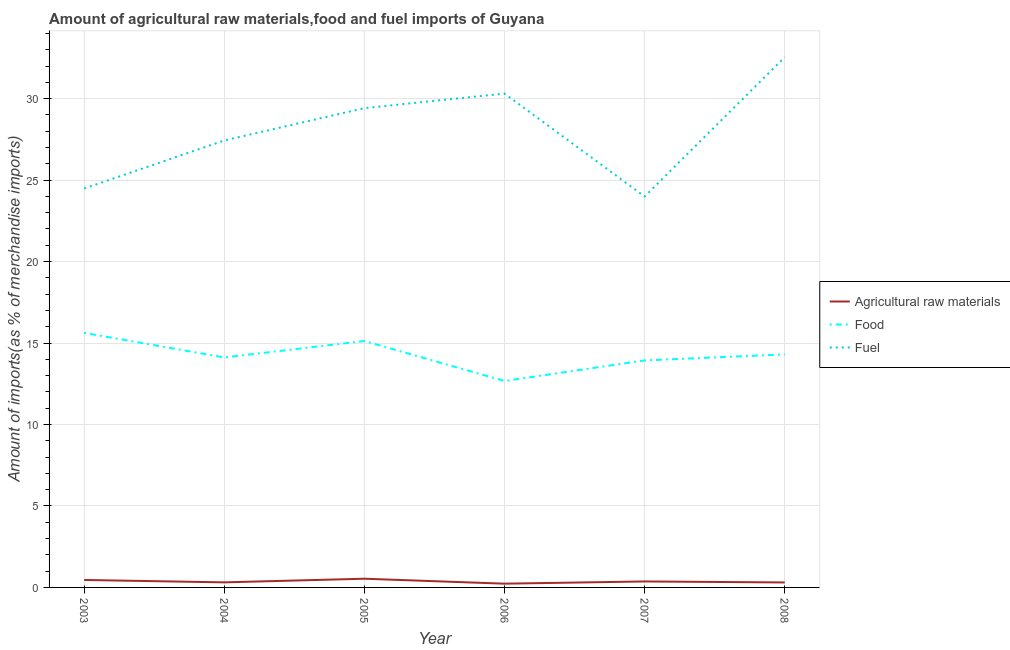Does the line corresponding to percentage of raw materials imports intersect with the line corresponding to percentage of fuel imports?
Ensure brevity in your answer.  No. What is the percentage of food imports in 2004?
Offer a very short reply. 14.11. Across all years, what is the maximum percentage of food imports?
Offer a very short reply. 15.62. Across all years, what is the minimum percentage of food imports?
Offer a very short reply. 12.67. What is the total percentage of raw materials imports in the graph?
Offer a very short reply. 2.21. What is the difference between the percentage of food imports in 2005 and that in 2008?
Your answer should be compact. 0.82. What is the difference between the percentage of raw materials imports in 2008 and the percentage of fuel imports in 2003?
Offer a very short reply. -24.18. What is the average percentage of raw materials imports per year?
Provide a succinct answer. 0.37. In the year 2008, what is the difference between the percentage of food imports and percentage of fuel imports?
Your response must be concise. -18.24. In how many years, is the percentage of raw materials imports greater than 21 %?
Your answer should be compact. 0. What is the ratio of the percentage of food imports in 2003 to that in 2005?
Your answer should be very brief. 1.03. Is the percentage of raw materials imports in 2005 less than that in 2006?
Offer a terse response. No. What is the difference between the highest and the second highest percentage of raw materials imports?
Keep it short and to the point. 0.08. What is the difference between the highest and the lowest percentage of raw materials imports?
Your answer should be compact. 0.3. In how many years, is the percentage of raw materials imports greater than the average percentage of raw materials imports taken over all years?
Provide a succinct answer. 2. Is the sum of the percentage of food imports in 2007 and 2008 greater than the maximum percentage of fuel imports across all years?
Offer a very short reply. No. Is the percentage of fuel imports strictly greater than the percentage of food imports over the years?
Your answer should be very brief. Yes. How many lines are there?
Offer a terse response. 3. What is the difference between two consecutive major ticks on the Y-axis?
Offer a very short reply. 5. Are the values on the major ticks of Y-axis written in scientific E-notation?
Keep it short and to the point. No. Does the graph contain any zero values?
Ensure brevity in your answer.  No. Where does the legend appear in the graph?
Provide a short and direct response. Center right. How many legend labels are there?
Keep it short and to the point. 3. What is the title of the graph?
Your response must be concise. Amount of agricultural raw materials,food and fuel imports of Guyana. What is the label or title of the Y-axis?
Offer a very short reply. Amount of imports(as % of merchandise imports). What is the Amount of imports(as % of merchandise imports) of Agricultural raw materials in 2003?
Keep it short and to the point. 0.46. What is the Amount of imports(as % of merchandise imports) in Food in 2003?
Give a very brief answer. 15.62. What is the Amount of imports(as % of merchandise imports) of Fuel in 2003?
Offer a very short reply. 24.48. What is the Amount of imports(as % of merchandise imports) in Agricultural raw materials in 2004?
Your answer should be compact. 0.31. What is the Amount of imports(as % of merchandise imports) of Food in 2004?
Your answer should be compact. 14.11. What is the Amount of imports(as % of merchandise imports) in Fuel in 2004?
Ensure brevity in your answer.  27.43. What is the Amount of imports(as % of merchandise imports) of Agricultural raw materials in 2005?
Your response must be concise. 0.53. What is the Amount of imports(as % of merchandise imports) of Food in 2005?
Give a very brief answer. 15.12. What is the Amount of imports(as % of merchandise imports) of Fuel in 2005?
Offer a terse response. 29.42. What is the Amount of imports(as % of merchandise imports) in Agricultural raw materials in 2006?
Ensure brevity in your answer.  0.23. What is the Amount of imports(as % of merchandise imports) in Food in 2006?
Give a very brief answer. 12.67. What is the Amount of imports(as % of merchandise imports) in Fuel in 2006?
Provide a short and direct response. 30.31. What is the Amount of imports(as % of merchandise imports) in Agricultural raw materials in 2007?
Offer a terse response. 0.37. What is the Amount of imports(as % of merchandise imports) of Food in 2007?
Make the answer very short. 13.93. What is the Amount of imports(as % of merchandise imports) in Fuel in 2007?
Offer a very short reply. 23.99. What is the Amount of imports(as % of merchandise imports) in Agricultural raw materials in 2008?
Your answer should be very brief. 0.3. What is the Amount of imports(as % of merchandise imports) of Food in 2008?
Your answer should be very brief. 14.3. What is the Amount of imports(as % of merchandise imports) in Fuel in 2008?
Make the answer very short. 32.54. Across all years, what is the maximum Amount of imports(as % of merchandise imports) in Agricultural raw materials?
Provide a short and direct response. 0.53. Across all years, what is the maximum Amount of imports(as % of merchandise imports) of Food?
Make the answer very short. 15.62. Across all years, what is the maximum Amount of imports(as % of merchandise imports) of Fuel?
Keep it short and to the point. 32.54. Across all years, what is the minimum Amount of imports(as % of merchandise imports) of Agricultural raw materials?
Make the answer very short. 0.23. Across all years, what is the minimum Amount of imports(as % of merchandise imports) in Food?
Ensure brevity in your answer.  12.67. Across all years, what is the minimum Amount of imports(as % of merchandise imports) of Fuel?
Offer a terse response. 23.99. What is the total Amount of imports(as % of merchandise imports) of Agricultural raw materials in the graph?
Your answer should be compact. 2.21. What is the total Amount of imports(as % of merchandise imports) in Food in the graph?
Offer a very short reply. 85.76. What is the total Amount of imports(as % of merchandise imports) in Fuel in the graph?
Provide a short and direct response. 168.17. What is the difference between the Amount of imports(as % of merchandise imports) in Agricultural raw materials in 2003 and that in 2004?
Offer a terse response. 0.15. What is the difference between the Amount of imports(as % of merchandise imports) of Food in 2003 and that in 2004?
Offer a terse response. 1.51. What is the difference between the Amount of imports(as % of merchandise imports) in Fuel in 2003 and that in 2004?
Provide a succinct answer. -2.95. What is the difference between the Amount of imports(as % of merchandise imports) of Agricultural raw materials in 2003 and that in 2005?
Give a very brief answer. -0.08. What is the difference between the Amount of imports(as % of merchandise imports) in Food in 2003 and that in 2005?
Give a very brief answer. 0.5. What is the difference between the Amount of imports(as % of merchandise imports) of Fuel in 2003 and that in 2005?
Give a very brief answer. -4.93. What is the difference between the Amount of imports(as % of merchandise imports) of Agricultural raw materials in 2003 and that in 2006?
Your answer should be very brief. 0.23. What is the difference between the Amount of imports(as % of merchandise imports) of Food in 2003 and that in 2006?
Your answer should be very brief. 2.95. What is the difference between the Amount of imports(as % of merchandise imports) of Fuel in 2003 and that in 2006?
Make the answer very short. -5.83. What is the difference between the Amount of imports(as % of merchandise imports) in Agricultural raw materials in 2003 and that in 2007?
Keep it short and to the point. 0.09. What is the difference between the Amount of imports(as % of merchandise imports) in Food in 2003 and that in 2007?
Ensure brevity in your answer.  1.69. What is the difference between the Amount of imports(as % of merchandise imports) of Fuel in 2003 and that in 2007?
Your answer should be very brief. 0.49. What is the difference between the Amount of imports(as % of merchandise imports) of Agricultural raw materials in 2003 and that in 2008?
Give a very brief answer. 0.15. What is the difference between the Amount of imports(as % of merchandise imports) of Food in 2003 and that in 2008?
Give a very brief answer. 1.32. What is the difference between the Amount of imports(as % of merchandise imports) of Fuel in 2003 and that in 2008?
Give a very brief answer. -8.06. What is the difference between the Amount of imports(as % of merchandise imports) of Agricultural raw materials in 2004 and that in 2005?
Provide a short and direct response. -0.22. What is the difference between the Amount of imports(as % of merchandise imports) of Food in 2004 and that in 2005?
Make the answer very short. -1.01. What is the difference between the Amount of imports(as % of merchandise imports) of Fuel in 2004 and that in 2005?
Keep it short and to the point. -1.98. What is the difference between the Amount of imports(as % of merchandise imports) in Agricultural raw materials in 2004 and that in 2006?
Make the answer very short. 0.08. What is the difference between the Amount of imports(as % of merchandise imports) in Food in 2004 and that in 2006?
Keep it short and to the point. 1.44. What is the difference between the Amount of imports(as % of merchandise imports) of Fuel in 2004 and that in 2006?
Make the answer very short. -2.88. What is the difference between the Amount of imports(as % of merchandise imports) in Agricultural raw materials in 2004 and that in 2007?
Your answer should be compact. -0.06. What is the difference between the Amount of imports(as % of merchandise imports) of Food in 2004 and that in 2007?
Ensure brevity in your answer.  0.18. What is the difference between the Amount of imports(as % of merchandise imports) in Fuel in 2004 and that in 2007?
Ensure brevity in your answer.  3.44. What is the difference between the Amount of imports(as % of merchandise imports) of Agricultural raw materials in 2004 and that in 2008?
Offer a terse response. 0.01. What is the difference between the Amount of imports(as % of merchandise imports) in Food in 2004 and that in 2008?
Make the answer very short. -0.19. What is the difference between the Amount of imports(as % of merchandise imports) of Fuel in 2004 and that in 2008?
Your response must be concise. -5.11. What is the difference between the Amount of imports(as % of merchandise imports) of Agricultural raw materials in 2005 and that in 2006?
Your answer should be compact. 0.3. What is the difference between the Amount of imports(as % of merchandise imports) in Food in 2005 and that in 2006?
Your response must be concise. 2.45. What is the difference between the Amount of imports(as % of merchandise imports) of Fuel in 2005 and that in 2006?
Provide a short and direct response. -0.89. What is the difference between the Amount of imports(as % of merchandise imports) in Agricultural raw materials in 2005 and that in 2007?
Offer a very short reply. 0.17. What is the difference between the Amount of imports(as % of merchandise imports) in Food in 2005 and that in 2007?
Offer a terse response. 1.19. What is the difference between the Amount of imports(as % of merchandise imports) in Fuel in 2005 and that in 2007?
Make the answer very short. 5.42. What is the difference between the Amount of imports(as % of merchandise imports) in Agricultural raw materials in 2005 and that in 2008?
Your answer should be compact. 0.23. What is the difference between the Amount of imports(as % of merchandise imports) of Food in 2005 and that in 2008?
Provide a succinct answer. 0.82. What is the difference between the Amount of imports(as % of merchandise imports) in Fuel in 2005 and that in 2008?
Provide a short and direct response. -3.13. What is the difference between the Amount of imports(as % of merchandise imports) of Agricultural raw materials in 2006 and that in 2007?
Keep it short and to the point. -0.14. What is the difference between the Amount of imports(as % of merchandise imports) in Food in 2006 and that in 2007?
Your answer should be compact. -1.26. What is the difference between the Amount of imports(as % of merchandise imports) of Fuel in 2006 and that in 2007?
Your answer should be very brief. 6.32. What is the difference between the Amount of imports(as % of merchandise imports) of Agricultural raw materials in 2006 and that in 2008?
Provide a succinct answer. -0.07. What is the difference between the Amount of imports(as % of merchandise imports) of Food in 2006 and that in 2008?
Ensure brevity in your answer.  -1.63. What is the difference between the Amount of imports(as % of merchandise imports) in Fuel in 2006 and that in 2008?
Provide a succinct answer. -2.23. What is the difference between the Amount of imports(as % of merchandise imports) in Agricultural raw materials in 2007 and that in 2008?
Give a very brief answer. 0.06. What is the difference between the Amount of imports(as % of merchandise imports) of Food in 2007 and that in 2008?
Offer a terse response. -0.37. What is the difference between the Amount of imports(as % of merchandise imports) in Fuel in 2007 and that in 2008?
Keep it short and to the point. -8.55. What is the difference between the Amount of imports(as % of merchandise imports) of Agricultural raw materials in 2003 and the Amount of imports(as % of merchandise imports) of Food in 2004?
Offer a terse response. -13.66. What is the difference between the Amount of imports(as % of merchandise imports) of Agricultural raw materials in 2003 and the Amount of imports(as % of merchandise imports) of Fuel in 2004?
Make the answer very short. -26.97. What is the difference between the Amount of imports(as % of merchandise imports) in Food in 2003 and the Amount of imports(as % of merchandise imports) in Fuel in 2004?
Give a very brief answer. -11.81. What is the difference between the Amount of imports(as % of merchandise imports) of Agricultural raw materials in 2003 and the Amount of imports(as % of merchandise imports) of Food in 2005?
Your answer should be compact. -14.67. What is the difference between the Amount of imports(as % of merchandise imports) of Agricultural raw materials in 2003 and the Amount of imports(as % of merchandise imports) of Fuel in 2005?
Offer a terse response. -28.96. What is the difference between the Amount of imports(as % of merchandise imports) of Food in 2003 and the Amount of imports(as % of merchandise imports) of Fuel in 2005?
Offer a terse response. -13.79. What is the difference between the Amount of imports(as % of merchandise imports) of Agricultural raw materials in 2003 and the Amount of imports(as % of merchandise imports) of Food in 2006?
Keep it short and to the point. -12.21. What is the difference between the Amount of imports(as % of merchandise imports) in Agricultural raw materials in 2003 and the Amount of imports(as % of merchandise imports) in Fuel in 2006?
Provide a succinct answer. -29.85. What is the difference between the Amount of imports(as % of merchandise imports) in Food in 2003 and the Amount of imports(as % of merchandise imports) in Fuel in 2006?
Your response must be concise. -14.69. What is the difference between the Amount of imports(as % of merchandise imports) of Agricultural raw materials in 2003 and the Amount of imports(as % of merchandise imports) of Food in 2007?
Provide a succinct answer. -13.47. What is the difference between the Amount of imports(as % of merchandise imports) in Agricultural raw materials in 2003 and the Amount of imports(as % of merchandise imports) in Fuel in 2007?
Your answer should be very brief. -23.53. What is the difference between the Amount of imports(as % of merchandise imports) of Food in 2003 and the Amount of imports(as % of merchandise imports) of Fuel in 2007?
Offer a very short reply. -8.37. What is the difference between the Amount of imports(as % of merchandise imports) in Agricultural raw materials in 2003 and the Amount of imports(as % of merchandise imports) in Food in 2008?
Give a very brief answer. -13.84. What is the difference between the Amount of imports(as % of merchandise imports) of Agricultural raw materials in 2003 and the Amount of imports(as % of merchandise imports) of Fuel in 2008?
Give a very brief answer. -32.09. What is the difference between the Amount of imports(as % of merchandise imports) of Food in 2003 and the Amount of imports(as % of merchandise imports) of Fuel in 2008?
Your answer should be very brief. -16.92. What is the difference between the Amount of imports(as % of merchandise imports) of Agricultural raw materials in 2004 and the Amount of imports(as % of merchandise imports) of Food in 2005?
Offer a terse response. -14.81. What is the difference between the Amount of imports(as % of merchandise imports) of Agricultural raw materials in 2004 and the Amount of imports(as % of merchandise imports) of Fuel in 2005?
Your answer should be very brief. -29.1. What is the difference between the Amount of imports(as % of merchandise imports) in Food in 2004 and the Amount of imports(as % of merchandise imports) in Fuel in 2005?
Offer a terse response. -15.3. What is the difference between the Amount of imports(as % of merchandise imports) in Agricultural raw materials in 2004 and the Amount of imports(as % of merchandise imports) in Food in 2006?
Keep it short and to the point. -12.36. What is the difference between the Amount of imports(as % of merchandise imports) of Agricultural raw materials in 2004 and the Amount of imports(as % of merchandise imports) of Fuel in 2006?
Your response must be concise. -30. What is the difference between the Amount of imports(as % of merchandise imports) in Food in 2004 and the Amount of imports(as % of merchandise imports) in Fuel in 2006?
Ensure brevity in your answer.  -16.2. What is the difference between the Amount of imports(as % of merchandise imports) in Agricultural raw materials in 2004 and the Amount of imports(as % of merchandise imports) in Food in 2007?
Offer a very short reply. -13.62. What is the difference between the Amount of imports(as % of merchandise imports) of Agricultural raw materials in 2004 and the Amount of imports(as % of merchandise imports) of Fuel in 2007?
Your answer should be compact. -23.68. What is the difference between the Amount of imports(as % of merchandise imports) of Food in 2004 and the Amount of imports(as % of merchandise imports) of Fuel in 2007?
Offer a very short reply. -9.88. What is the difference between the Amount of imports(as % of merchandise imports) in Agricultural raw materials in 2004 and the Amount of imports(as % of merchandise imports) in Food in 2008?
Provide a succinct answer. -13.99. What is the difference between the Amount of imports(as % of merchandise imports) of Agricultural raw materials in 2004 and the Amount of imports(as % of merchandise imports) of Fuel in 2008?
Keep it short and to the point. -32.23. What is the difference between the Amount of imports(as % of merchandise imports) in Food in 2004 and the Amount of imports(as % of merchandise imports) in Fuel in 2008?
Give a very brief answer. -18.43. What is the difference between the Amount of imports(as % of merchandise imports) of Agricultural raw materials in 2005 and the Amount of imports(as % of merchandise imports) of Food in 2006?
Keep it short and to the point. -12.13. What is the difference between the Amount of imports(as % of merchandise imports) of Agricultural raw materials in 2005 and the Amount of imports(as % of merchandise imports) of Fuel in 2006?
Keep it short and to the point. -29.77. What is the difference between the Amount of imports(as % of merchandise imports) of Food in 2005 and the Amount of imports(as % of merchandise imports) of Fuel in 2006?
Offer a very short reply. -15.19. What is the difference between the Amount of imports(as % of merchandise imports) of Agricultural raw materials in 2005 and the Amount of imports(as % of merchandise imports) of Food in 2007?
Offer a very short reply. -13.4. What is the difference between the Amount of imports(as % of merchandise imports) in Agricultural raw materials in 2005 and the Amount of imports(as % of merchandise imports) in Fuel in 2007?
Offer a very short reply. -23.46. What is the difference between the Amount of imports(as % of merchandise imports) of Food in 2005 and the Amount of imports(as % of merchandise imports) of Fuel in 2007?
Your answer should be very brief. -8.87. What is the difference between the Amount of imports(as % of merchandise imports) in Agricultural raw materials in 2005 and the Amount of imports(as % of merchandise imports) in Food in 2008?
Provide a short and direct response. -13.77. What is the difference between the Amount of imports(as % of merchandise imports) in Agricultural raw materials in 2005 and the Amount of imports(as % of merchandise imports) in Fuel in 2008?
Make the answer very short. -32.01. What is the difference between the Amount of imports(as % of merchandise imports) of Food in 2005 and the Amount of imports(as % of merchandise imports) of Fuel in 2008?
Your response must be concise. -17.42. What is the difference between the Amount of imports(as % of merchandise imports) of Agricultural raw materials in 2006 and the Amount of imports(as % of merchandise imports) of Food in 2007?
Make the answer very short. -13.7. What is the difference between the Amount of imports(as % of merchandise imports) of Agricultural raw materials in 2006 and the Amount of imports(as % of merchandise imports) of Fuel in 2007?
Ensure brevity in your answer.  -23.76. What is the difference between the Amount of imports(as % of merchandise imports) in Food in 2006 and the Amount of imports(as % of merchandise imports) in Fuel in 2007?
Offer a terse response. -11.32. What is the difference between the Amount of imports(as % of merchandise imports) in Agricultural raw materials in 2006 and the Amount of imports(as % of merchandise imports) in Food in 2008?
Offer a very short reply. -14.07. What is the difference between the Amount of imports(as % of merchandise imports) in Agricultural raw materials in 2006 and the Amount of imports(as % of merchandise imports) in Fuel in 2008?
Provide a succinct answer. -32.31. What is the difference between the Amount of imports(as % of merchandise imports) in Food in 2006 and the Amount of imports(as % of merchandise imports) in Fuel in 2008?
Your response must be concise. -19.87. What is the difference between the Amount of imports(as % of merchandise imports) of Agricultural raw materials in 2007 and the Amount of imports(as % of merchandise imports) of Food in 2008?
Your answer should be very brief. -13.94. What is the difference between the Amount of imports(as % of merchandise imports) of Agricultural raw materials in 2007 and the Amount of imports(as % of merchandise imports) of Fuel in 2008?
Provide a succinct answer. -32.18. What is the difference between the Amount of imports(as % of merchandise imports) in Food in 2007 and the Amount of imports(as % of merchandise imports) in Fuel in 2008?
Ensure brevity in your answer.  -18.61. What is the average Amount of imports(as % of merchandise imports) in Agricultural raw materials per year?
Keep it short and to the point. 0.37. What is the average Amount of imports(as % of merchandise imports) of Food per year?
Make the answer very short. 14.29. What is the average Amount of imports(as % of merchandise imports) of Fuel per year?
Your answer should be very brief. 28.03. In the year 2003, what is the difference between the Amount of imports(as % of merchandise imports) of Agricultural raw materials and Amount of imports(as % of merchandise imports) of Food?
Give a very brief answer. -15.17. In the year 2003, what is the difference between the Amount of imports(as % of merchandise imports) of Agricultural raw materials and Amount of imports(as % of merchandise imports) of Fuel?
Provide a succinct answer. -24.03. In the year 2003, what is the difference between the Amount of imports(as % of merchandise imports) in Food and Amount of imports(as % of merchandise imports) in Fuel?
Provide a short and direct response. -8.86. In the year 2004, what is the difference between the Amount of imports(as % of merchandise imports) of Agricultural raw materials and Amount of imports(as % of merchandise imports) of Food?
Make the answer very short. -13.8. In the year 2004, what is the difference between the Amount of imports(as % of merchandise imports) in Agricultural raw materials and Amount of imports(as % of merchandise imports) in Fuel?
Your answer should be compact. -27.12. In the year 2004, what is the difference between the Amount of imports(as % of merchandise imports) of Food and Amount of imports(as % of merchandise imports) of Fuel?
Keep it short and to the point. -13.32. In the year 2005, what is the difference between the Amount of imports(as % of merchandise imports) in Agricultural raw materials and Amount of imports(as % of merchandise imports) in Food?
Your response must be concise. -14.59. In the year 2005, what is the difference between the Amount of imports(as % of merchandise imports) in Agricultural raw materials and Amount of imports(as % of merchandise imports) in Fuel?
Provide a short and direct response. -28.88. In the year 2005, what is the difference between the Amount of imports(as % of merchandise imports) of Food and Amount of imports(as % of merchandise imports) of Fuel?
Provide a short and direct response. -14.29. In the year 2006, what is the difference between the Amount of imports(as % of merchandise imports) of Agricultural raw materials and Amount of imports(as % of merchandise imports) of Food?
Ensure brevity in your answer.  -12.44. In the year 2006, what is the difference between the Amount of imports(as % of merchandise imports) of Agricultural raw materials and Amount of imports(as % of merchandise imports) of Fuel?
Your response must be concise. -30.08. In the year 2006, what is the difference between the Amount of imports(as % of merchandise imports) of Food and Amount of imports(as % of merchandise imports) of Fuel?
Your response must be concise. -17.64. In the year 2007, what is the difference between the Amount of imports(as % of merchandise imports) of Agricultural raw materials and Amount of imports(as % of merchandise imports) of Food?
Your answer should be very brief. -13.56. In the year 2007, what is the difference between the Amount of imports(as % of merchandise imports) in Agricultural raw materials and Amount of imports(as % of merchandise imports) in Fuel?
Offer a terse response. -23.62. In the year 2007, what is the difference between the Amount of imports(as % of merchandise imports) of Food and Amount of imports(as % of merchandise imports) of Fuel?
Offer a terse response. -10.06. In the year 2008, what is the difference between the Amount of imports(as % of merchandise imports) of Agricultural raw materials and Amount of imports(as % of merchandise imports) of Food?
Keep it short and to the point. -14. In the year 2008, what is the difference between the Amount of imports(as % of merchandise imports) of Agricultural raw materials and Amount of imports(as % of merchandise imports) of Fuel?
Your response must be concise. -32.24. In the year 2008, what is the difference between the Amount of imports(as % of merchandise imports) of Food and Amount of imports(as % of merchandise imports) of Fuel?
Your answer should be compact. -18.24. What is the ratio of the Amount of imports(as % of merchandise imports) in Agricultural raw materials in 2003 to that in 2004?
Your answer should be compact. 1.47. What is the ratio of the Amount of imports(as % of merchandise imports) in Food in 2003 to that in 2004?
Give a very brief answer. 1.11. What is the ratio of the Amount of imports(as % of merchandise imports) in Fuel in 2003 to that in 2004?
Your response must be concise. 0.89. What is the ratio of the Amount of imports(as % of merchandise imports) of Agricultural raw materials in 2003 to that in 2005?
Give a very brief answer. 0.86. What is the ratio of the Amount of imports(as % of merchandise imports) in Food in 2003 to that in 2005?
Offer a terse response. 1.03. What is the ratio of the Amount of imports(as % of merchandise imports) of Fuel in 2003 to that in 2005?
Offer a terse response. 0.83. What is the ratio of the Amount of imports(as % of merchandise imports) in Agricultural raw materials in 2003 to that in 2006?
Offer a very short reply. 1.99. What is the ratio of the Amount of imports(as % of merchandise imports) of Food in 2003 to that in 2006?
Your answer should be very brief. 1.23. What is the ratio of the Amount of imports(as % of merchandise imports) in Fuel in 2003 to that in 2006?
Ensure brevity in your answer.  0.81. What is the ratio of the Amount of imports(as % of merchandise imports) of Agricultural raw materials in 2003 to that in 2007?
Give a very brief answer. 1.25. What is the ratio of the Amount of imports(as % of merchandise imports) in Food in 2003 to that in 2007?
Make the answer very short. 1.12. What is the ratio of the Amount of imports(as % of merchandise imports) in Fuel in 2003 to that in 2007?
Make the answer very short. 1.02. What is the ratio of the Amount of imports(as % of merchandise imports) of Agricultural raw materials in 2003 to that in 2008?
Your answer should be compact. 1.5. What is the ratio of the Amount of imports(as % of merchandise imports) in Food in 2003 to that in 2008?
Your response must be concise. 1.09. What is the ratio of the Amount of imports(as % of merchandise imports) of Fuel in 2003 to that in 2008?
Offer a very short reply. 0.75. What is the ratio of the Amount of imports(as % of merchandise imports) in Agricultural raw materials in 2004 to that in 2005?
Your response must be concise. 0.58. What is the ratio of the Amount of imports(as % of merchandise imports) of Food in 2004 to that in 2005?
Make the answer very short. 0.93. What is the ratio of the Amount of imports(as % of merchandise imports) in Fuel in 2004 to that in 2005?
Make the answer very short. 0.93. What is the ratio of the Amount of imports(as % of merchandise imports) of Agricultural raw materials in 2004 to that in 2006?
Ensure brevity in your answer.  1.35. What is the ratio of the Amount of imports(as % of merchandise imports) of Food in 2004 to that in 2006?
Ensure brevity in your answer.  1.11. What is the ratio of the Amount of imports(as % of merchandise imports) of Fuel in 2004 to that in 2006?
Provide a short and direct response. 0.91. What is the ratio of the Amount of imports(as % of merchandise imports) of Agricultural raw materials in 2004 to that in 2007?
Make the answer very short. 0.85. What is the ratio of the Amount of imports(as % of merchandise imports) in Food in 2004 to that in 2007?
Give a very brief answer. 1.01. What is the ratio of the Amount of imports(as % of merchandise imports) in Fuel in 2004 to that in 2007?
Keep it short and to the point. 1.14. What is the ratio of the Amount of imports(as % of merchandise imports) in Agricultural raw materials in 2004 to that in 2008?
Ensure brevity in your answer.  1.02. What is the ratio of the Amount of imports(as % of merchandise imports) in Fuel in 2004 to that in 2008?
Make the answer very short. 0.84. What is the ratio of the Amount of imports(as % of merchandise imports) of Agricultural raw materials in 2005 to that in 2006?
Offer a very short reply. 2.32. What is the ratio of the Amount of imports(as % of merchandise imports) of Food in 2005 to that in 2006?
Provide a short and direct response. 1.19. What is the ratio of the Amount of imports(as % of merchandise imports) in Fuel in 2005 to that in 2006?
Give a very brief answer. 0.97. What is the ratio of the Amount of imports(as % of merchandise imports) of Agricultural raw materials in 2005 to that in 2007?
Offer a very short reply. 1.46. What is the ratio of the Amount of imports(as % of merchandise imports) in Food in 2005 to that in 2007?
Keep it short and to the point. 1.09. What is the ratio of the Amount of imports(as % of merchandise imports) of Fuel in 2005 to that in 2007?
Your answer should be very brief. 1.23. What is the ratio of the Amount of imports(as % of merchandise imports) in Agricultural raw materials in 2005 to that in 2008?
Keep it short and to the point. 1.75. What is the ratio of the Amount of imports(as % of merchandise imports) of Food in 2005 to that in 2008?
Keep it short and to the point. 1.06. What is the ratio of the Amount of imports(as % of merchandise imports) of Fuel in 2005 to that in 2008?
Provide a short and direct response. 0.9. What is the ratio of the Amount of imports(as % of merchandise imports) in Agricultural raw materials in 2006 to that in 2007?
Ensure brevity in your answer.  0.63. What is the ratio of the Amount of imports(as % of merchandise imports) of Food in 2006 to that in 2007?
Give a very brief answer. 0.91. What is the ratio of the Amount of imports(as % of merchandise imports) in Fuel in 2006 to that in 2007?
Your response must be concise. 1.26. What is the ratio of the Amount of imports(as % of merchandise imports) of Agricultural raw materials in 2006 to that in 2008?
Offer a very short reply. 0.76. What is the ratio of the Amount of imports(as % of merchandise imports) in Food in 2006 to that in 2008?
Provide a succinct answer. 0.89. What is the ratio of the Amount of imports(as % of merchandise imports) of Fuel in 2006 to that in 2008?
Provide a short and direct response. 0.93. What is the ratio of the Amount of imports(as % of merchandise imports) of Agricultural raw materials in 2007 to that in 2008?
Your answer should be very brief. 1.2. What is the ratio of the Amount of imports(as % of merchandise imports) in Food in 2007 to that in 2008?
Offer a very short reply. 0.97. What is the ratio of the Amount of imports(as % of merchandise imports) of Fuel in 2007 to that in 2008?
Provide a succinct answer. 0.74. What is the difference between the highest and the second highest Amount of imports(as % of merchandise imports) in Agricultural raw materials?
Offer a terse response. 0.08. What is the difference between the highest and the second highest Amount of imports(as % of merchandise imports) of Food?
Provide a short and direct response. 0.5. What is the difference between the highest and the second highest Amount of imports(as % of merchandise imports) in Fuel?
Make the answer very short. 2.23. What is the difference between the highest and the lowest Amount of imports(as % of merchandise imports) in Agricultural raw materials?
Keep it short and to the point. 0.3. What is the difference between the highest and the lowest Amount of imports(as % of merchandise imports) of Food?
Make the answer very short. 2.95. What is the difference between the highest and the lowest Amount of imports(as % of merchandise imports) in Fuel?
Your response must be concise. 8.55. 